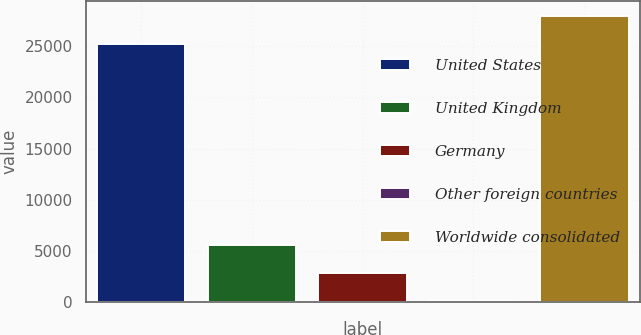Convert chart to OTSL. <chart><loc_0><loc_0><loc_500><loc_500><bar_chart><fcel>United States<fcel>United Kingdom<fcel>Germany<fcel>Other foreign countries<fcel>Worldwide consolidated<nl><fcel>25255<fcel>5577.6<fcel>2851.8<fcel>126<fcel>27980.8<nl></chart> 